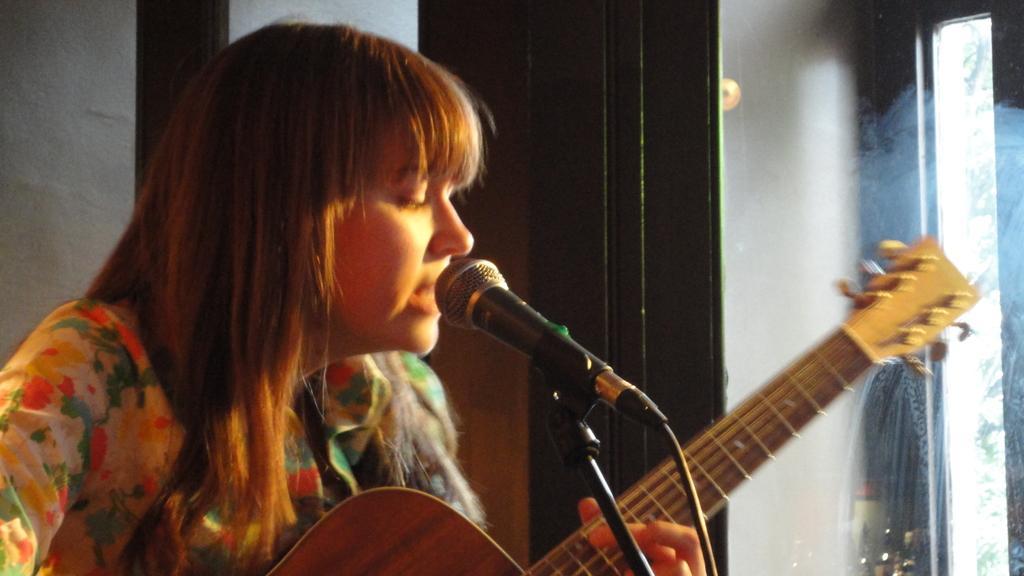How would you summarize this image in a sentence or two? in this image there is a woman singing, she is playing a guitar. there is a microphone and its stand present in front of her. at the right side there is a window 